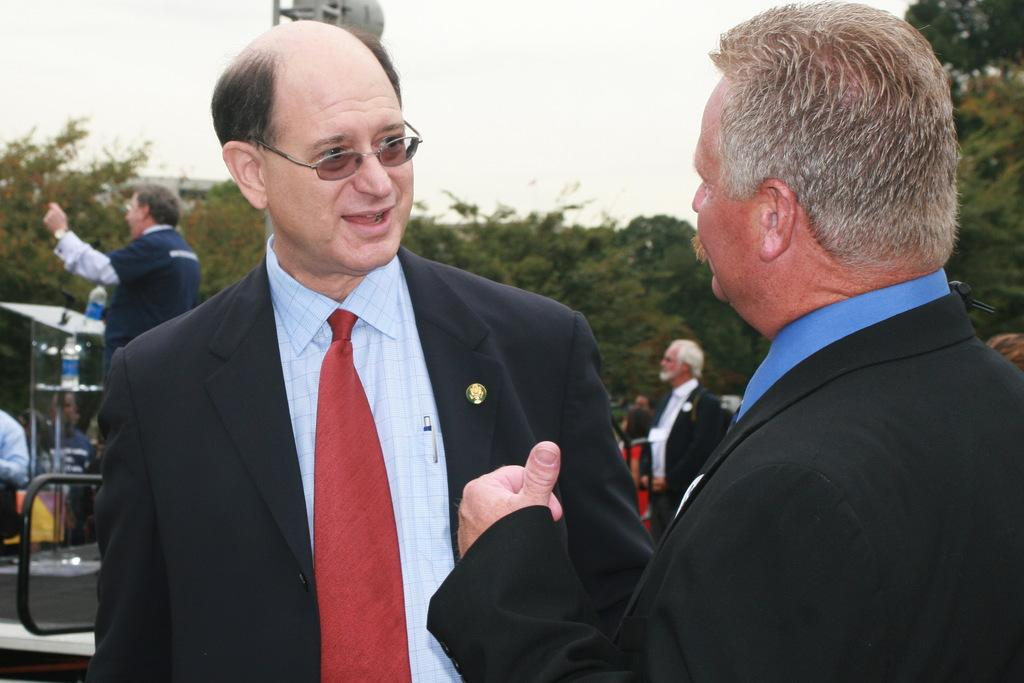What can be seen in the image? There are people standing in the image. What is visible in the background of the image? There are trees and the sky in the background of the image. How many brothers are present in the image? There is no information about brothers in the image, so we cannot determine their presence or number. 